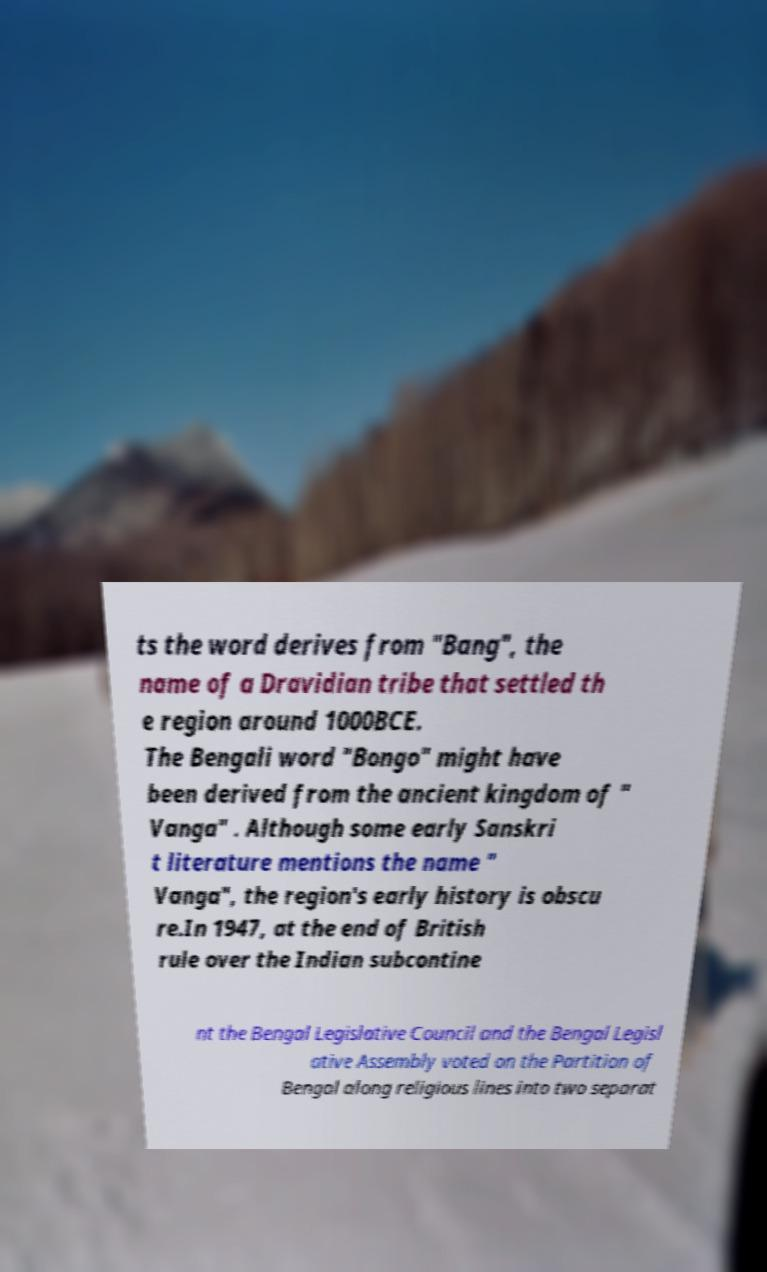I need the written content from this picture converted into text. Can you do that? ts the word derives from "Bang", the name of a Dravidian tribe that settled th e region around 1000BCE. The Bengali word "Bongo" might have been derived from the ancient kingdom of " Vanga" . Although some early Sanskri t literature mentions the name " Vanga", the region's early history is obscu re.In 1947, at the end of British rule over the Indian subcontine nt the Bengal Legislative Council and the Bengal Legisl ative Assembly voted on the Partition of Bengal along religious lines into two separat 